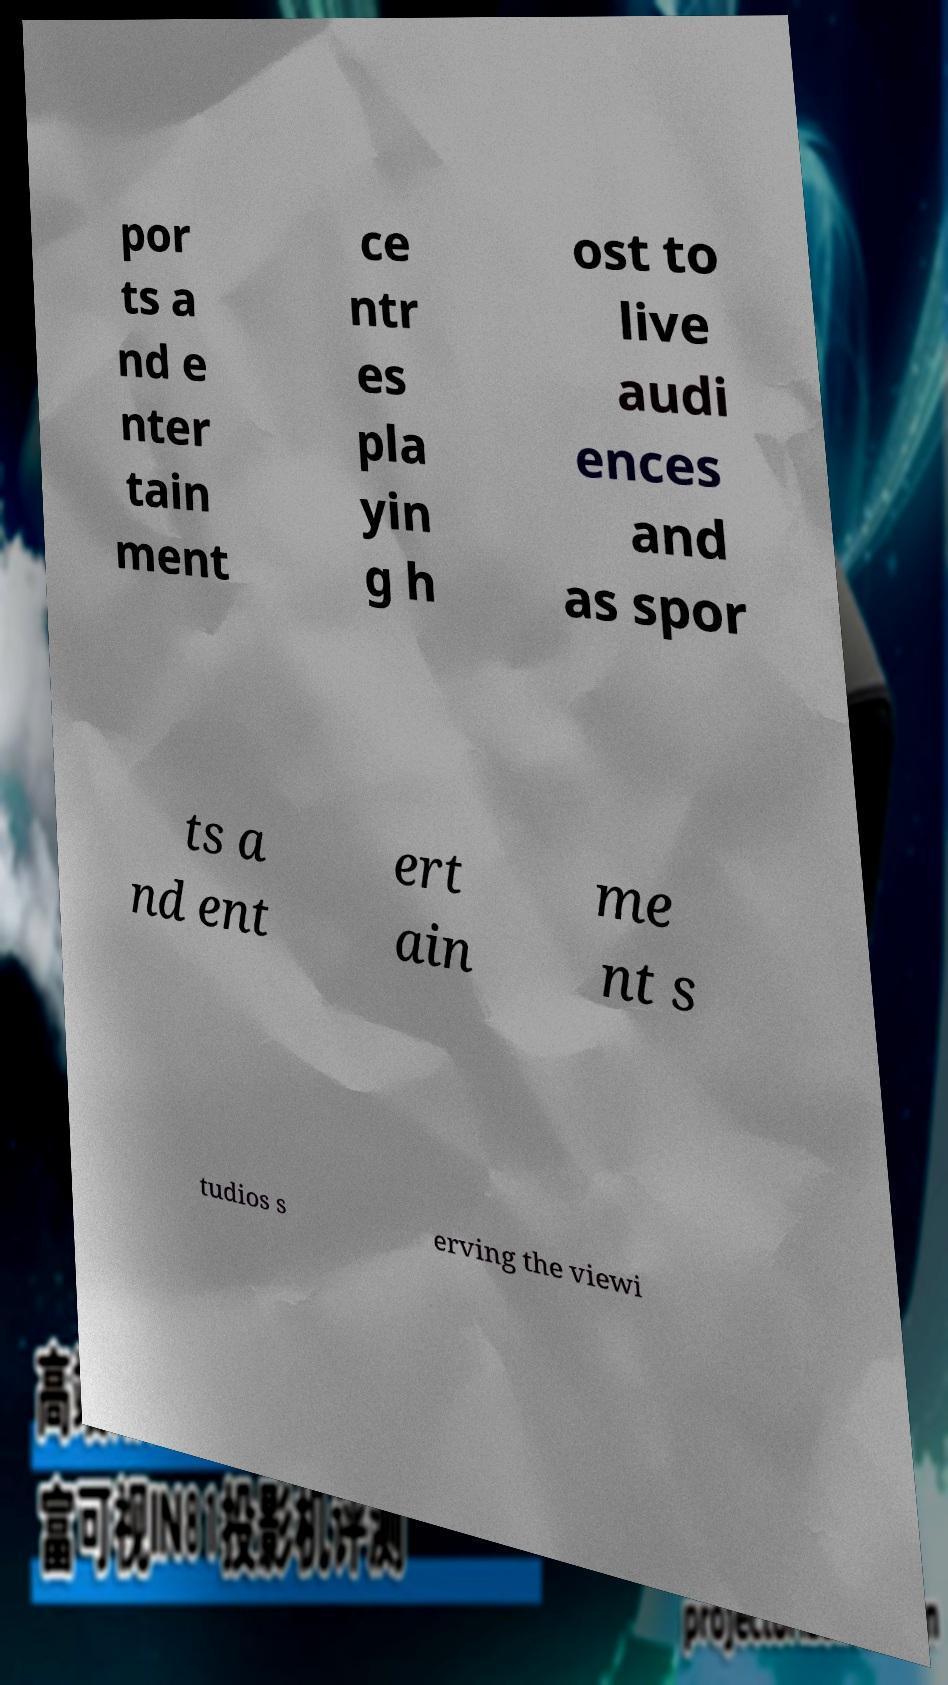What messages or text are displayed in this image? I need them in a readable, typed format. por ts a nd e nter tain ment ce ntr es pla yin g h ost to live audi ences and as spor ts a nd ent ert ain me nt s tudios s erving the viewi 